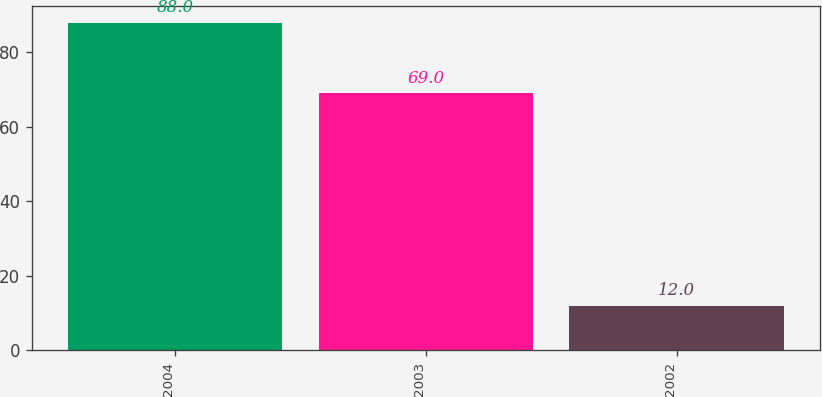Convert chart to OTSL. <chart><loc_0><loc_0><loc_500><loc_500><bar_chart><fcel>2004<fcel>2003<fcel>2002<nl><fcel>88<fcel>69<fcel>12<nl></chart> 